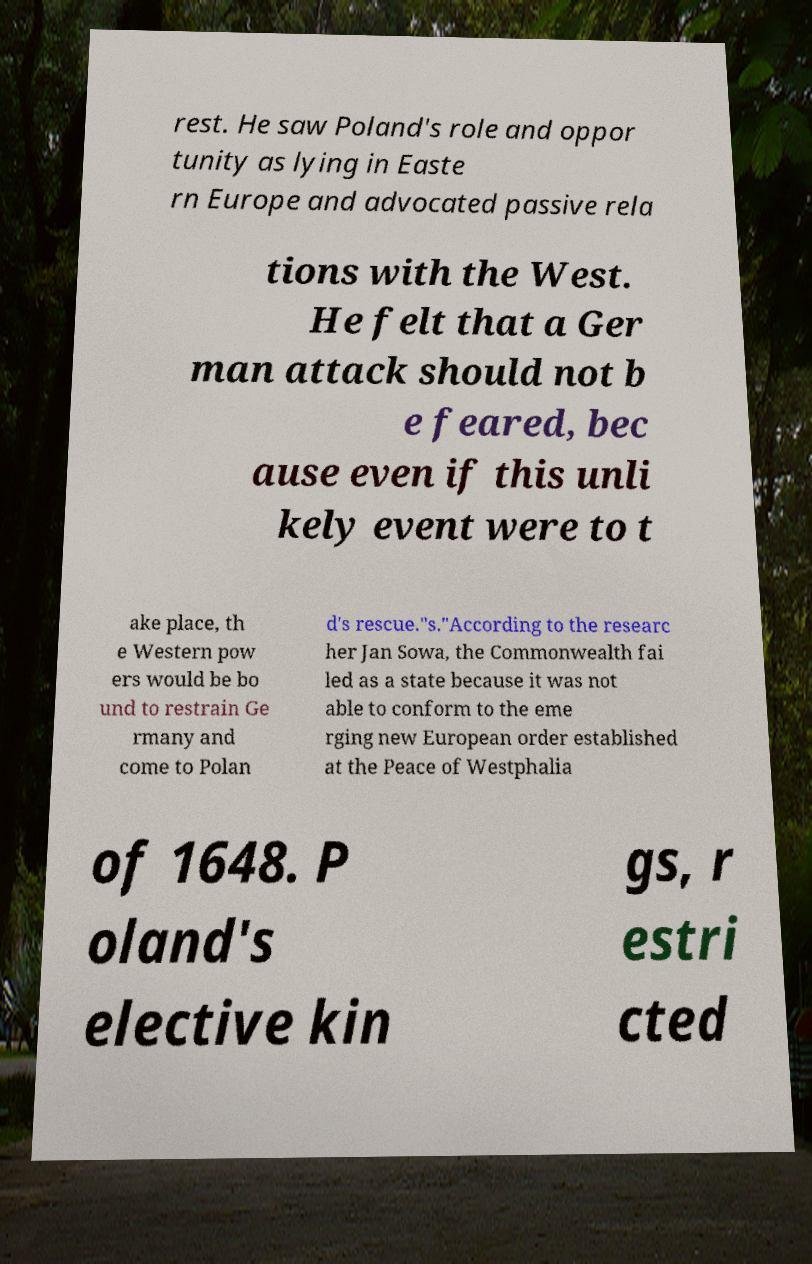What messages or text are displayed in this image? I need them in a readable, typed format. rest. He saw Poland's role and oppor tunity as lying in Easte rn Europe and advocated passive rela tions with the West. He felt that a Ger man attack should not b e feared, bec ause even if this unli kely event were to t ake place, th e Western pow ers would be bo und to restrain Ge rmany and come to Polan d's rescue."s."According to the researc her Jan Sowa, the Commonwealth fai led as a state because it was not able to conform to the eme rging new European order established at the Peace of Westphalia of 1648. P oland's elective kin gs, r estri cted 